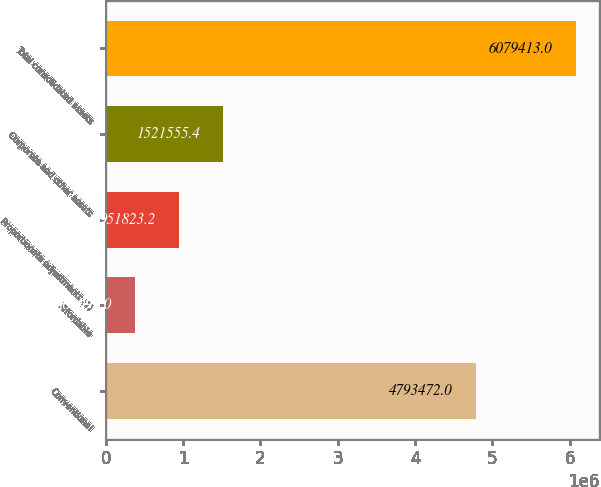<chart> <loc_0><loc_0><loc_500><loc_500><bar_chart><fcel>Conventional<fcel>Affordable<fcel>Proportionate adjustments (1)<fcel>Corporate and other assets<fcel>Total consolidated assets<nl><fcel>4.79347e+06<fcel>382091<fcel>951823<fcel>1.52156e+06<fcel>6.07941e+06<nl></chart> 